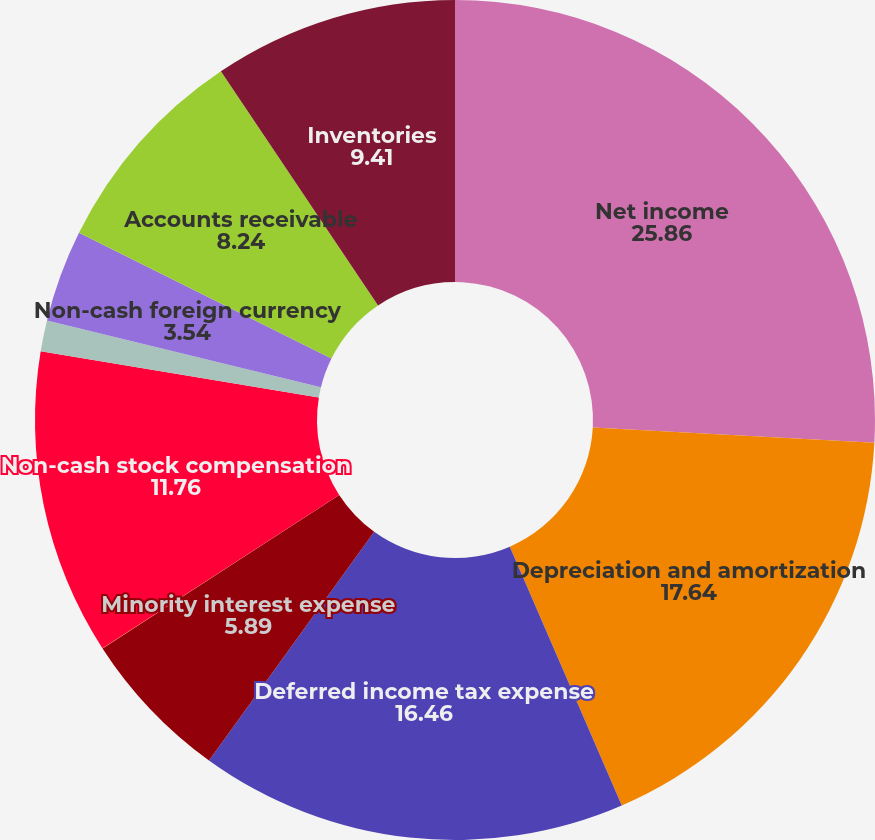Convert chart to OTSL. <chart><loc_0><loc_0><loc_500><loc_500><pie_chart><fcel>Net income<fcel>Depreciation and amortization<fcel>Deferred income tax expense<fcel>Minority interest expense<fcel>Equity in (income) loss of<fcel>Non-cash stock compensation<fcel>Non-cash provision for bad<fcel>Non-cash foreign currency<fcel>Accounts receivable<fcel>Inventories<nl><fcel>25.86%<fcel>17.64%<fcel>16.46%<fcel>5.89%<fcel>0.01%<fcel>11.76%<fcel>1.19%<fcel>3.54%<fcel>8.24%<fcel>9.41%<nl></chart> 